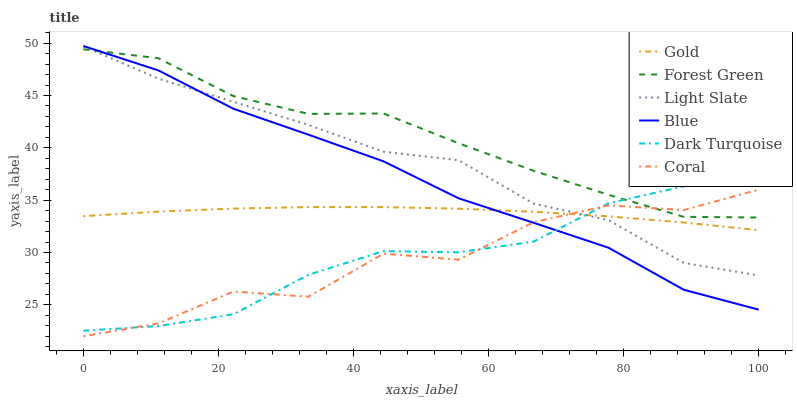Does Coral have the minimum area under the curve?
Answer yes or no. Yes. Does Forest Green have the maximum area under the curve?
Answer yes or no. Yes. Does Gold have the minimum area under the curve?
Answer yes or no. No. Does Gold have the maximum area under the curve?
Answer yes or no. No. Is Gold the smoothest?
Answer yes or no. Yes. Is Coral the roughest?
Answer yes or no. Yes. Is Light Slate the smoothest?
Answer yes or no. No. Is Light Slate the roughest?
Answer yes or no. No. Does Coral have the lowest value?
Answer yes or no. Yes. Does Gold have the lowest value?
Answer yes or no. No. Does Blue have the highest value?
Answer yes or no. Yes. Does Light Slate have the highest value?
Answer yes or no. No. Is Gold less than Forest Green?
Answer yes or no. Yes. Is Forest Green greater than Gold?
Answer yes or no. Yes. Does Dark Turquoise intersect Forest Green?
Answer yes or no. Yes. Is Dark Turquoise less than Forest Green?
Answer yes or no. No. Is Dark Turquoise greater than Forest Green?
Answer yes or no. No. Does Gold intersect Forest Green?
Answer yes or no. No. 